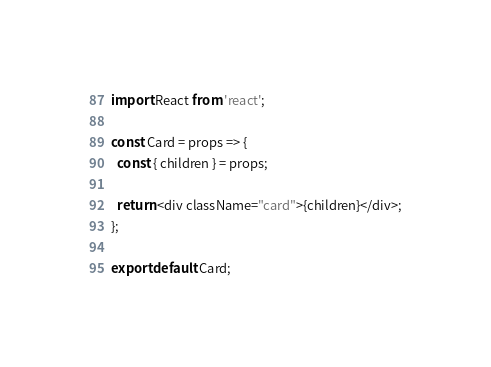Convert code to text. <code><loc_0><loc_0><loc_500><loc_500><_JavaScript_>import React from 'react';

const Card = props => {
  const { children } = props;

  return <div className="card">{children}</div>;
};

export default Card;
</code> 